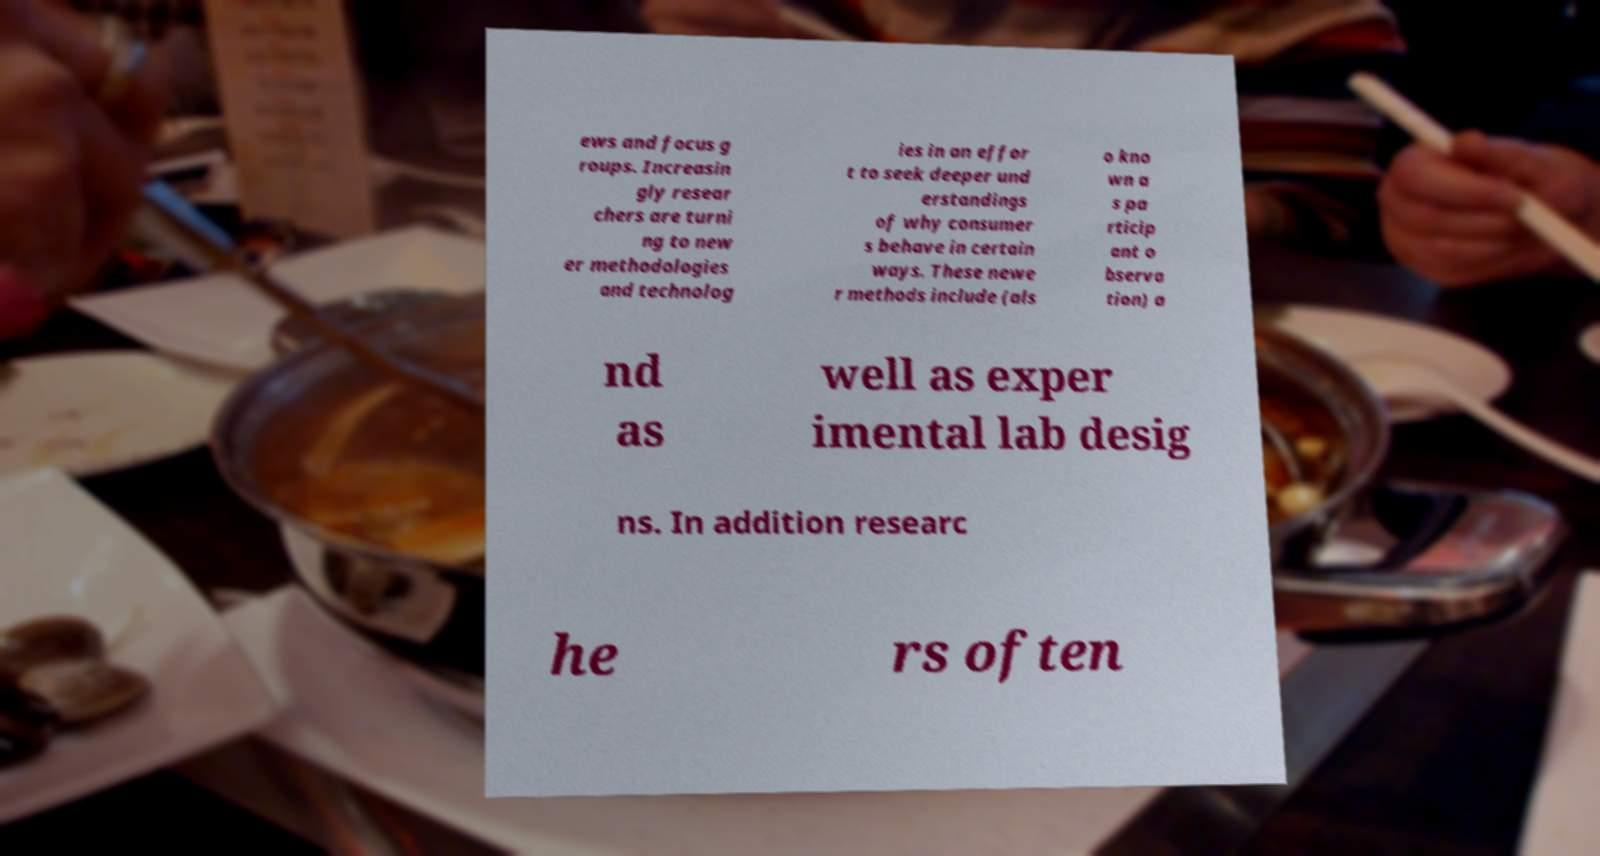Could you assist in decoding the text presented in this image and type it out clearly? ews and focus g roups. Increasin gly resear chers are turni ng to new er methodologies and technolog ies in an effor t to seek deeper und erstandings of why consumer s behave in certain ways. These newe r methods include (als o kno wn a s pa rticip ant o bserva tion) a nd as well as exper imental lab desig ns. In addition researc he rs often 